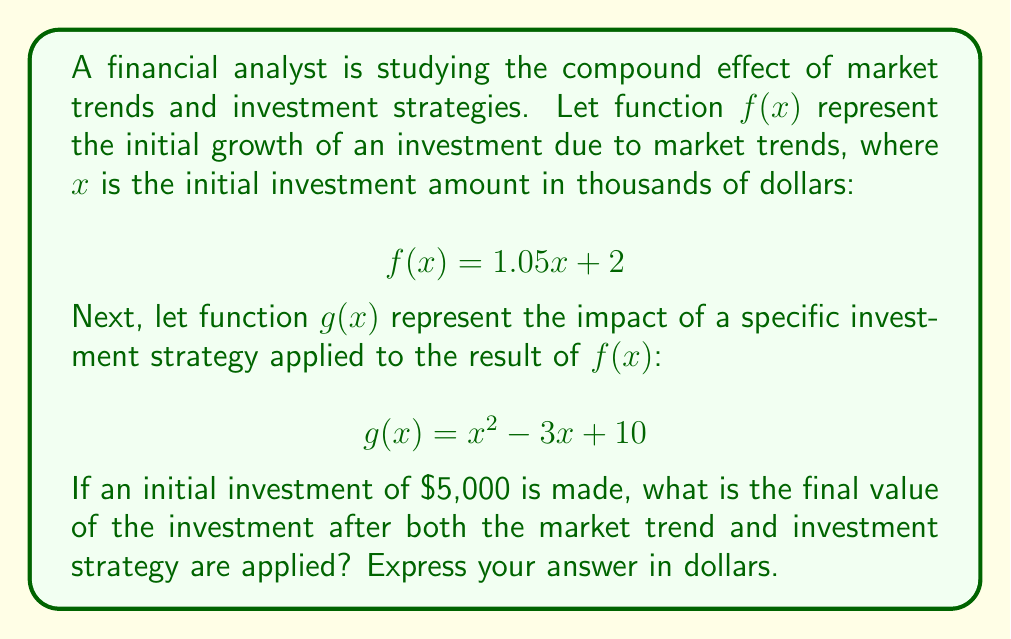Can you solve this math problem? To solve this problem, we need to compose the functions $f$ and $g$, then evaluate the result for the initial investment of $\$5,000$. Let's break it down step-by-step:

1) First, we need to compose $g(f(x))$. This means we replace every $x$ in $g(x)$ with $f(x)$:

   $g(f(x)) = (f(x))^2 - 3(f(x)) + 10$

2) Now, let's substitute $f(x) = 1.05x + 2$ into this equation:

   $g(f(x)) = (1.05x + 2)^2 - 3(1.05x + 2) + 10$

3) Let's expand this:
   
   $g(f(x)) = (1.05x + 2)^2 - 3.15x - 6 + 10$
   $g(f(x)) = 1.1025x^2 + 4.2x + 4 - 3.15x - 6 + 10$
   $g(f(x)) = 1.1025x^2 + 1.05x + 8$

4) Now we have our composed function. Let's evaluate it for $x = 5$ (since the initial investment is $\$5,000$, which is 5 thousand dollars):

   $g(f(5)) = 1.1025(5)^2 + 1.05(5) + 8$
   $g(f(5)) = 1.1025(25) + 5.25 + 8$
   $g(f(5)) = 27.5625 + 5.25 + 8$
   $g(f(5)) = 40.8125$

5) This result is in thousands of dollars, so we need to multiply by 1000 to get the final amount in dollars:

   $40.8125 * 1000 = 40,812.50$

Therefore, the final value of the investment is $\$40,812.50$.
Answer: $\$40,812.50$ 